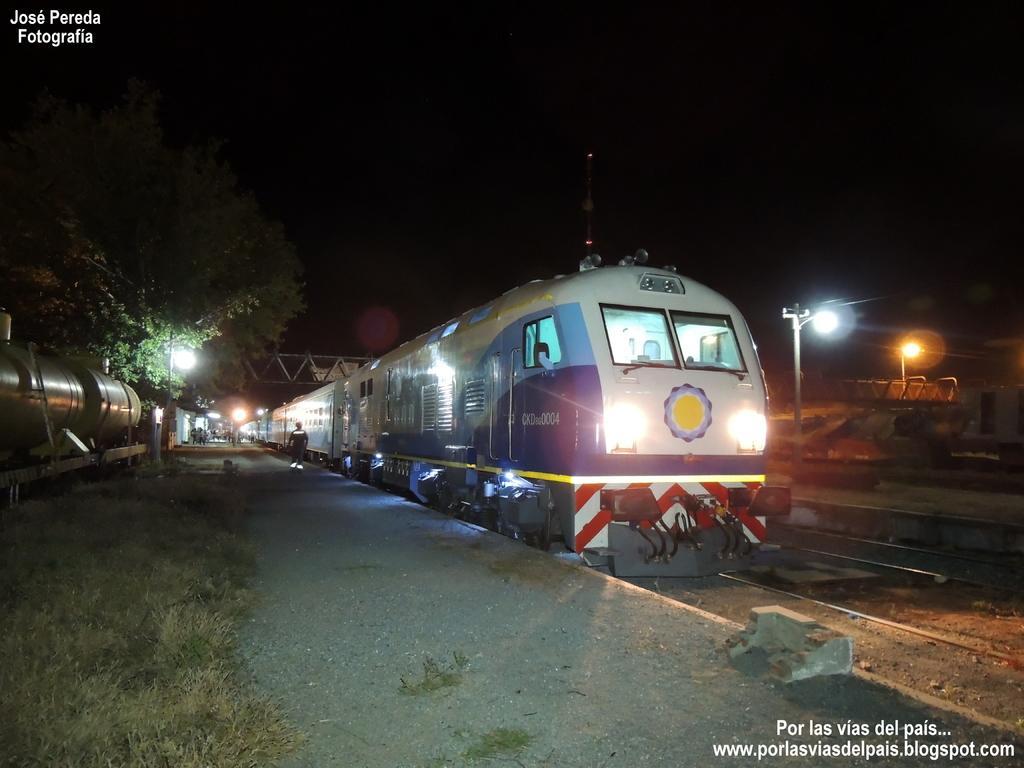Could you give a brief overview of what you see in this image? This is a railway station. These are the lights. This is a tree and the sky is very dark. Here at the left side of the train we can see one person standing. This is a railway track. 